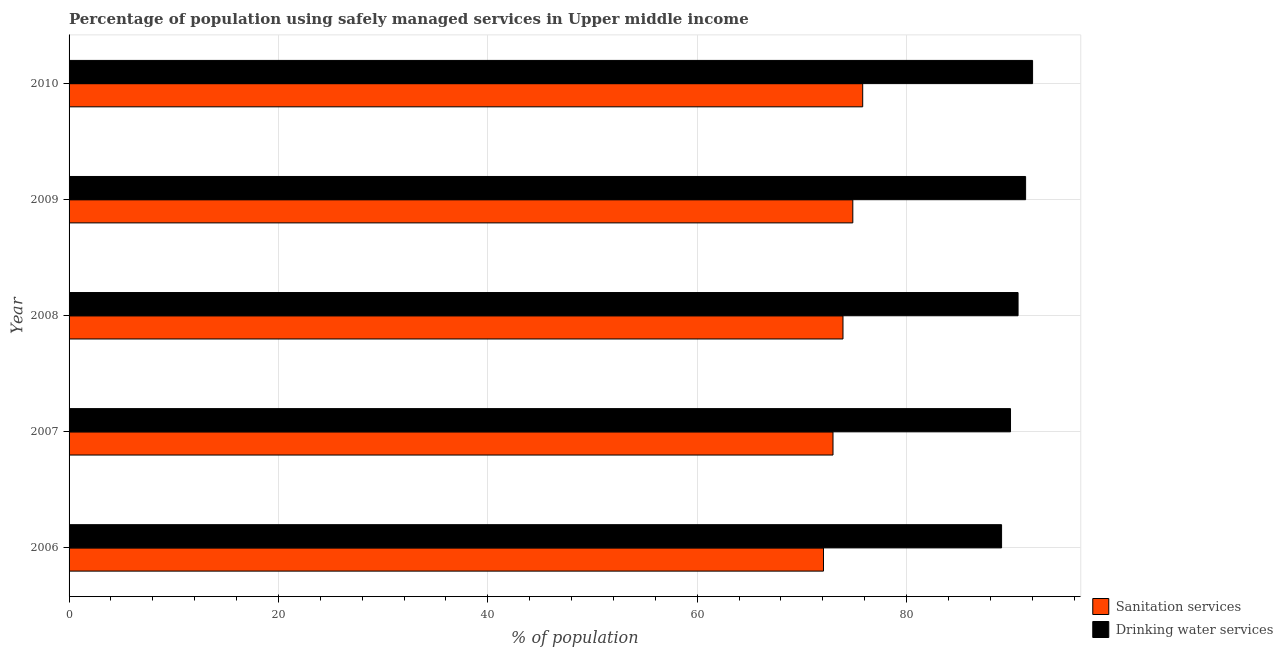How many groups of bars are there?
Offer a terse response. 5. Are the number of bars per tick equal to the number of legend labels?
Your response must be concise. Yes. How many bars are there on the 3rd tick from the top?
Provide a succinct answer. 2. What is the percentage of population who used drinking water services in 2009?
Your answer should be very brief. 91.38. Across all years, what is the maximum percentage of population who used drinking water services?
Provide a short and direct response. 92.04. Across all years, what is the minimum percentage of population who used drinking water services?
Your answer should be very brief. 89.08. What is the total percentage of population who used sanitation services in the graph?
Ensure brevity in your answer.  369.66. What is the difference between the percentage of population who used sanitation services in 2006 and that in 2007?
Your answer should be compact. -0.91. What is the difference between the percentage of population who used sanitation services in 2010 and the percentage of population who used drinking water services in 2007?
Give a very brief answer. -14.12. What is the average percentage of population who used sanitation services per year?
Provide a succinct answer. 73.93. In the year 2007, what is the difference between the percentage of population who used drinking water services and percentage of population who used sanitation services?
Your answer should be compact. 16.96. In how many years, is the percentage of population who used drinking water services greater than 92 %?
Provide a succinct answer. 1. Is the percentage of population who used sanitation services in 2007 less than that in 2009?
Provide a short and direct response. Yes. Is the difference between the percentage of population who used drinking water services in 2006 and 2008 greater than the difference between the percentage of population who used sanitation services in 2006 and 2008?
Ensure brevity in your answer.  Yes. What is the difference between the highest and the second highest percentage of population who used sanitation services?
Give a very brief answer. 0.94. What is the difference between the highest and the lowest percentage of population who used drinking water services?
Provide a short and direct response. 2.96. In how many years, is the percentage of population who used sanitation services greater than the average percentage of population who used sanitation services taken over all years?
Make the answer very short. 2. Is the sum of the percentage of population who used drinking water services in 2007 and 2009 greater than the maximum percentage of population who used sanitation services across all years?
Provide a short and direct response. Yes. What does the 1st bar from the top in 2010 represents?
Offer a terse response. Drinking water services. What does the 1st bar from the bottom in 2008 represents?
Keep it short and to the point. Sanitation services. How many bars are there?
Your answer should be compact. 10. Are all the bars in the graph horizontal?
Your answer should be very brief. Yes. How many years are there in the graph?
Provide a succinct answer. 5. What is the difference between two consecutive major ticks on the X-axis?
Offer a very short reply. 20. Are the values on the major ticks of X-axis written in scientific E-notation?
Ensure brevity in your answer.  No. Does the graph contain any zero values?
Offer a very short reply. No. Does the graph contain grids?
Offer a very short reply. Yes. How many legend labels are there?
Make the answer very short. 2. How are the legend labels stacked?
Your answer should be very brief. Vertical. What is the title of the graph?
Provide a short and direct response. Percentage of population using safely managed services in Upper middle income. What is the label or title of the X-axis?
Your answer should be compact. % of population. What is the label or title of the Y-axis?
Your response must be concise. Year. What is the % of population of Sanitation services in 2006?
Provide a succinct answer. 72.07. What is the % of population of Drinking water services in 2006?
Provide a succinct answer. 89.08. What is the % of population of Sanitation services in 2007?
Your answer should be very brief. 72.98. What is the % of population of Drinking water services in 2007?
Give a very brief answer. 89.93. What is the % of population of Sanitation services in 2008?
Your response must be concise. 73.93. What is the % of population in Drinking water services in 2008?
Your answer should be very brief. 90.66. What is the % of population in Sanitation services in 2009?
Your response must be concise. 74.87. What is the % of population of Drinking water services in 2009?
Your answer should be compact. 91.38. What is the % of population in Sanitation services in 2010?
Give a very brief answer. 75.81. What is the % of population of Drinking water services in 2010?
Your answer should be very brief. 92.04. Across all years, what is the maximum % of population of Sanitation services?
Give a very brief answer. 75.81. Across all years, what is the maximum % of population of Drinking water services?
Offer a very short reply. 92.04. Across all years, what is the minimum % of population in Sanitation services?
Ensure brevity in your answer.  72.07. Across all years, what is the minimum % of population in Drinking water services?
Make the answer very short. 89.08. What is the total % of population in Sanitation services in the graph?
Ensure brevity in your answer.  369.66. What is the total % of population of Drinking water services in the graph?
Provide a short and direct response. 453.09. What is the difference between the % of population in Sanitation services in 2006 and that in 2007?
Ensure brevity in your answer.  -0.91. What is the difference between the % of population in Drinking water services in 2006 and that in 2007?
Ensure brevity in your answer.  -0.85. What is the difference between the % of population in Sanitation services in 2006 and that in 2008?
Make the answer very short. -1.86. What is the difference between the % of population of Drinking water services in 2006 and that in 2008?
Keep it short and to the point. -1.57. What is the difference between the % of population in Sanitation services in 2006 and that in 2009?
Give a very brief answer. -2.8. What is the difference between the % of population of Drinking water services in 2006 and that in 2009?
Provide a succinct answer. -2.3. What is the difference between the % of population of Sanitation services in 2006 and that in 2010?
Offer a terse response. -3.75. What is the difference between the % of population of Drinking water services in 2006 and that in 2010?
Ensure brevity in your answer.  -2.96. What is the difference between the % of population of Sanitation services in 2007 and that in 2008?
Make the answer very short. -0.95. What is the difference between the % of population in Drinking water services in 2007 and that in 2008?
Ensure brevity in your answer.  -0.72. What is the difference between the % of population of Sanitation services in 2007 and that in 2009?
Your response must be concise. -1.89. What is the difference between the % of population in Drinking water services in 2007 and that in 2009?
Offer a very short reply. -1.44. What is the difference between the % of population of Sanitation services in 2007 and that in 2010?
Give a very brief answer. -2.84. What is the difference between the % of population of Drinking water services in 2007 and that in 2010?
Offer a very short reply. -2.11. What is the difference between the % of population in Sanitation services in 2008 and that in 2009?
Give a very brief answer. -0.94. What is the difference between the % of population of Drinking water services in 2008 and that in 2009?
Your answer should be very brief. -0.72. What is the difference between the % of population in Sanitation services in 2008 and that in 2010?
Your response must be concise. -1.88. What is the difference between the % of population in Drinking water services in 2008 and that in 2010?
Offer a very short reply. -1.39. What is the difference between the % of population of Sanitation services in 2009 and that in 2010?
Ensure brevity in your answer.  -0.94. What is the difference between the % of population of Drinking water services in 2009 and that in 2010?
Make the answer very short. -0.67. What is the difference between the % of population in Sanitation services in 2006 and the % of population in Drinking water services in 2007?
Make the answer very short. -17.87. What is the difference between the % of population of Sanitation services in 2006 and the % of population of Drinking water services in 2008?
Keep it short and to the point. -18.59. What is the difference between the % of population in Sanitation services in 2006 and the % of population in Drinking water services in 2009?
Offer a very short reply. -19.31. What is the difference between the % of population in Sanitation services in 2006 and the % of population in Drinking water services in 2010?
Give a very brief answer. -19.97. What is the difference between the % of population in Sanitation services in 2007 and the % of population in Drinking water services in 2008?
Provide a short and direct response. -17.68. What is the difference between the % of population in Sanitation services in 2007 and the % of population in Drinking water services in 2009?
Offer a terse response. -18.4. What is the difference between the % of population in Sanitation services in 2007 and the % of population in Drinking water services in 2010?
Give a very brief answer. -19.07. What is the difference between the % of population in Sanitation services in 2008 and the % of population in Drinking water services in 2009?
Give a very brief answer. -17.45. What is the difference between the % of population in Sanitation services in 2008 and the % of population in Drinking water services in 2010?
Provide a short and direct response. -18.11. What is the difference between the % of population of Sanitation services in 2009 and the % of population of Drinking water services in 2010?
Make the answer very short. -17.17. What is the average % of population in Sanitation services per year?
Make the answer very short. 73.93. What is the average % of population of Drinking water services per year?
Your answer should be compact. 90.62. In the year 2006, what is the difference between the % of population in Sanitation services and % of population in Drinking water services?
Provide a succinct answer. -17.01. In the year 2007, what is the difference between the % of population of Sanitation services and % of population of Drinking water services?
Keep it short and to the point. -16.96. In the year 2008, what is the difference between the % of population in Sanitation services and % of population in Drinking water services?
Keep it short and to the point. -16.72. In the year 2009, what is the difference between the % of population of Sanitation services and % of population of Drinking water services?
Provide a short and direct response. -16.51. In the year 2010, what is the difference between the % of population in Sanitation services and % of population in Drinking water services?
Keep it short and to the point. -16.23. What is the ratio of the % of population of Sanitation services in 2006 to that in 2007?
Provide a short and direct response. 0.99. What is the ratio of the % of population of Drinking water services in 2006 to that in 2007?
Make the answer very short. 0.99. What is the ratio of the % of population in Sanitation services in 2006 to that in 2008?
Your answer should be very brief. 0.97. What is the ratio of the % of population in Drinking water services in 2006 to that in 2008?
Provide a succinct answer. 0.98. What is the ratio of the % of population in Sanitation services in 2006 to that in 2009?
Your answer should be compact. 0.96. What is the ratio of the % of population in Drinking water services in 2006 to that in 2009?
Your answer should be very brief. 0.97. What is the ratio of the % of population of Sanitation services in 2006 to that in 2010?
Provide a short and direct response. 0.95. What is the ratio of the % of population of Drinking water services in 2006 to that in 2010?
Provide a succinct answer. 0.97. What is the ratio of the % of population of Sanitation services in 2007 to that in 2008?
Offer a very short reply. 0.99. What is the ratio of the % of population of Sanitation services in 2007 to that in 2009?
Ensure brevity in your answer.  0.97. What is the ratio of the % of population of Drinking water services in 2007 to that in 2009?
Your answer should be compact. 0.98. What is the ratio of the % of population of Sanitation services in 2007 to that in 2010?
Offer a very short reply. 0.96. What is the ratio of the % of population in Drinking water services in 2007 to that in 2010?
Make the answer very short. 0.98. What is the ratio of the % of population of Sanitation services in 2008 to that in 2009?
Provide a succinct answer. 0.99. What is the ratio of the % of population in Drinking water services in 2008 to that in 2009?
Offer a very short reply. 0.99. What is the ratio of the % of population in Sanitation services in 2008 to that in 2010?
Keep it short and to the point. 0.98. What is the ratio of the % of population in Drinking water services in 2008 to that in 2010?
Make the answer very short. 0.98. What is the ratio of the % of population of Sanitation services in 2009 to that in 2010?
Ensure brevity in your answer.  0.99. What is the ratio of the % of population of Drinking water services in 2009 to that in 2010?
Your response must be concise. 0.99. What is the difference between the highest and the second highest % of population of Sanitation services?
Keep it short and to the point. 0.94. What is the difference between the highest and the second highest % of population in Drinking water services?
Offer a very short reply. 0.67. What is the difference between the highest and the lowest % of population of Sanitation services?
Your response must be concise. 3.75. What is the difference between the highest and the lowest % of population in Drinking water services?
Offer a terse response. 2.96. 